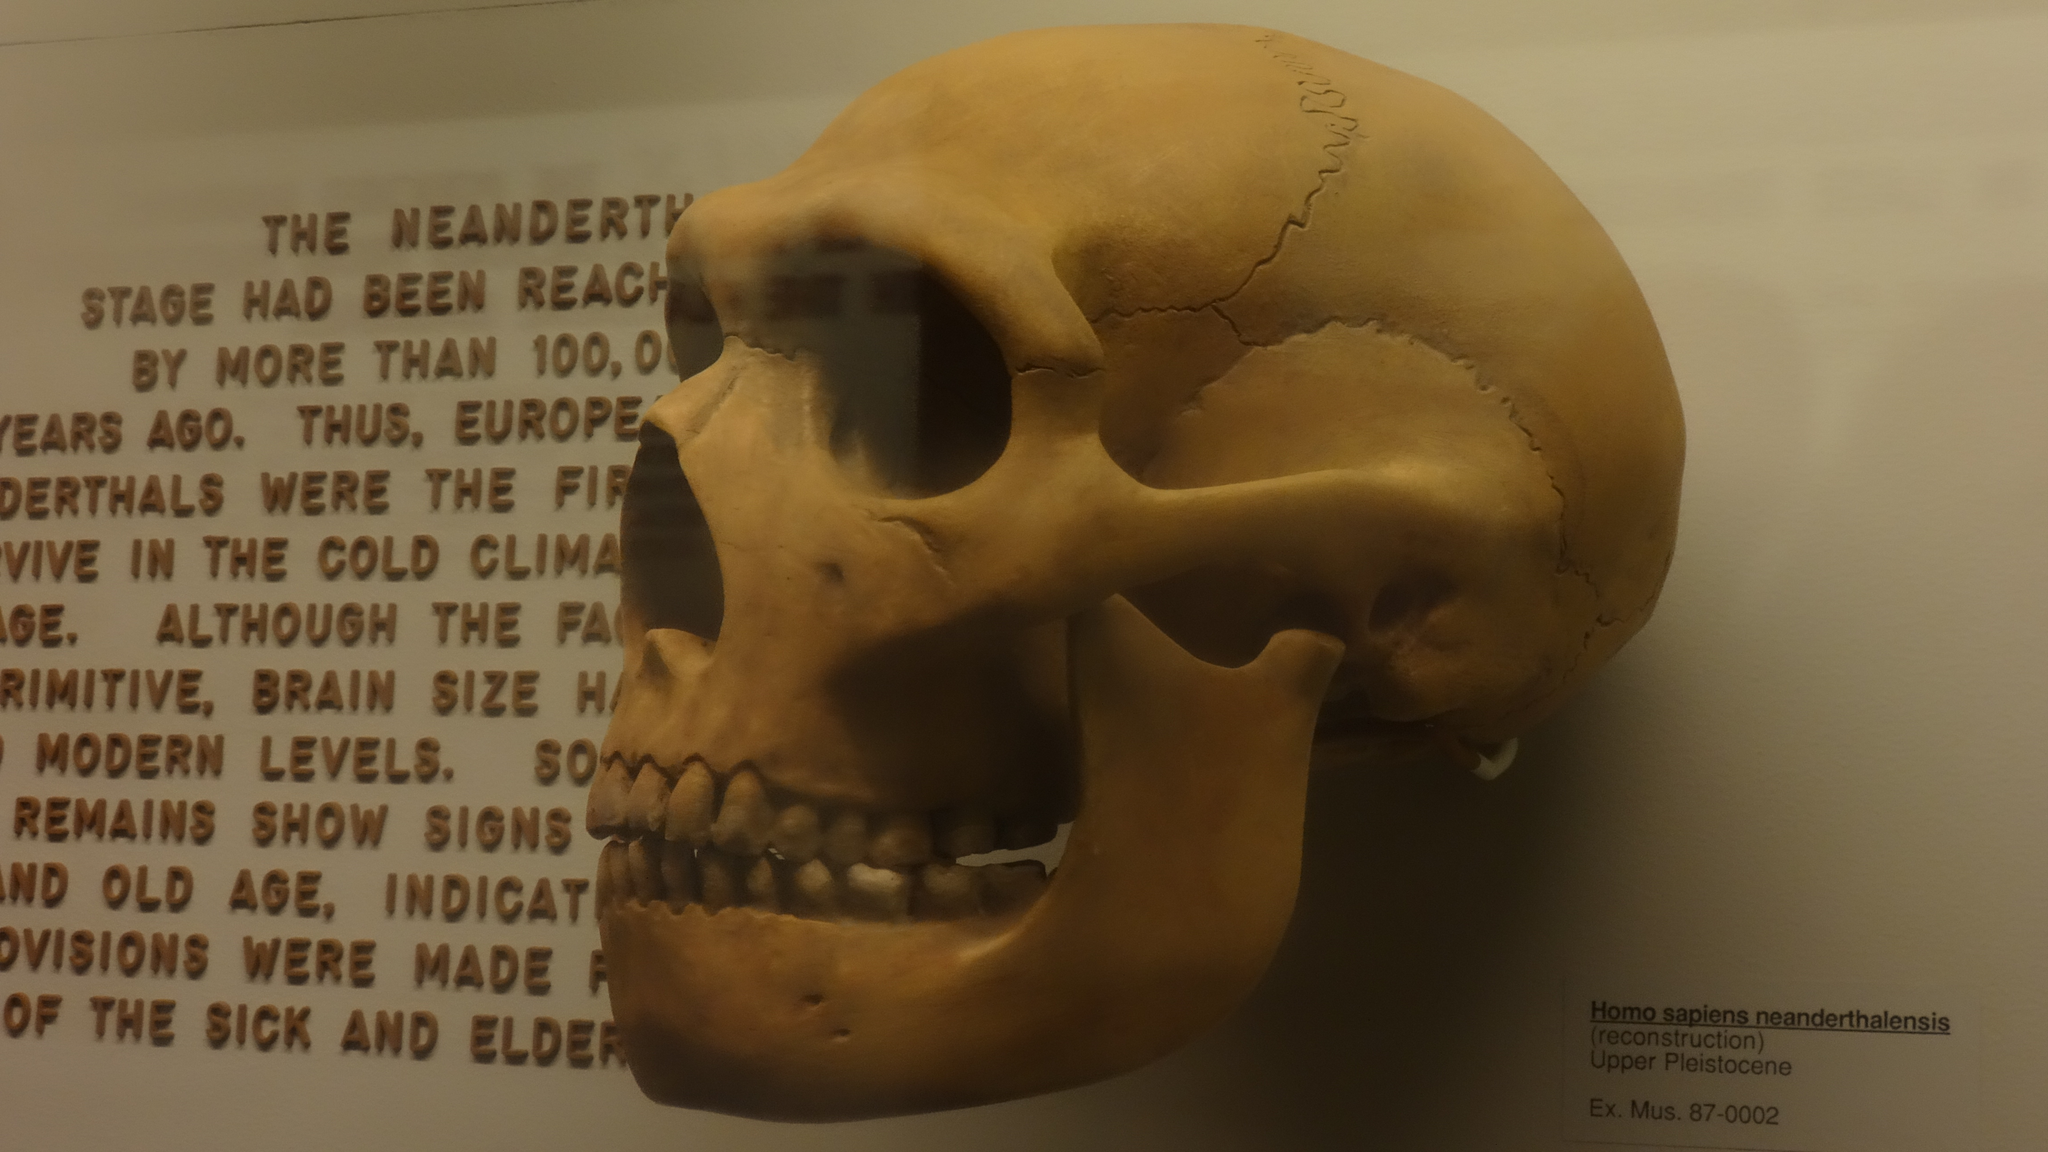In one or two sentences, can you explain what this image depicts? In this image we can see a skull and text on the left side of the image. 